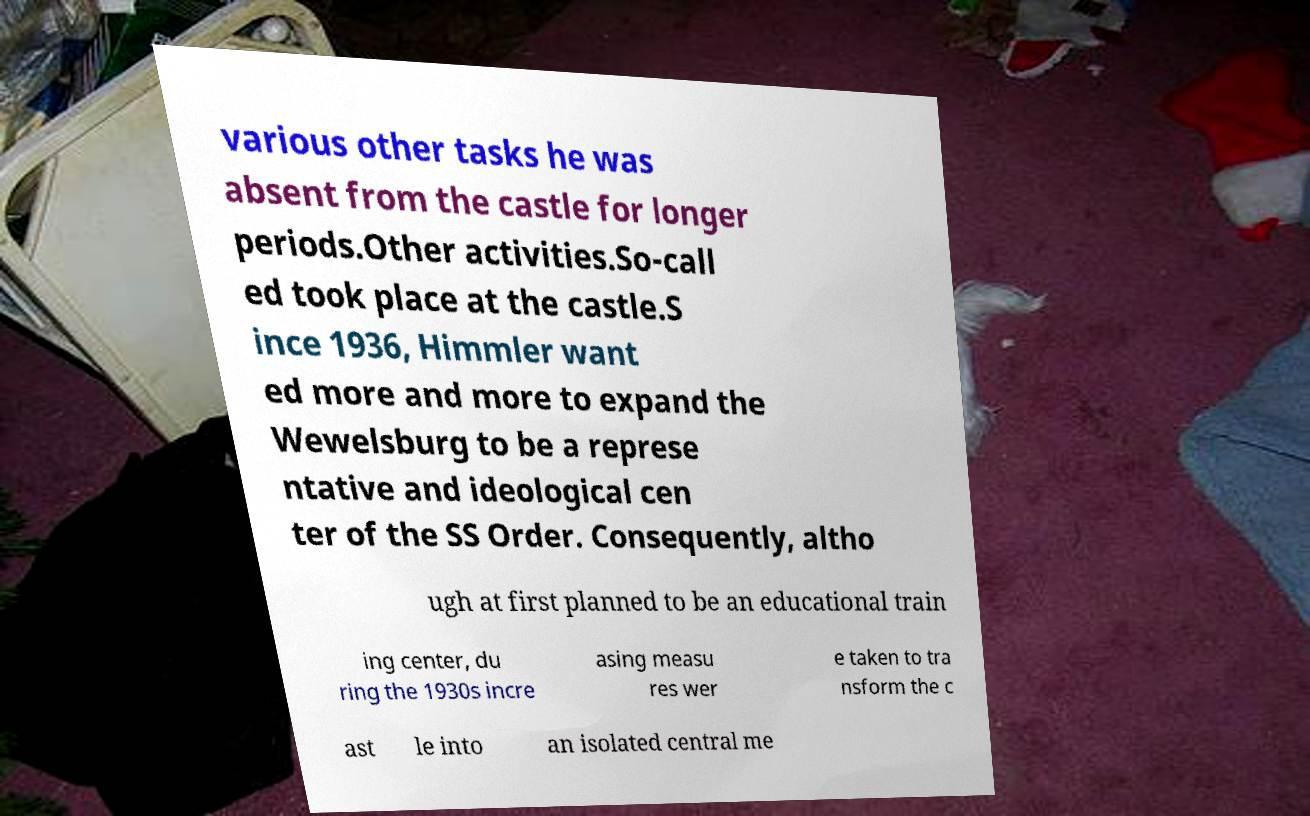Please identify and transcribe the text found in this image. various other tasks he was absent from the castle for longer periods.Other activities.So-call ed took place at the castle.S ince 1936, Himmler want ed more and more to expand the Wewelsburg to be a represe ntative and ideological cen ter of the SS Order. Consequently, altho ugh at first planned to be an educational train ing center, du ring the 1930s incre asing measu res wer e taken to tra nsform the c ast le into an isolated central me 